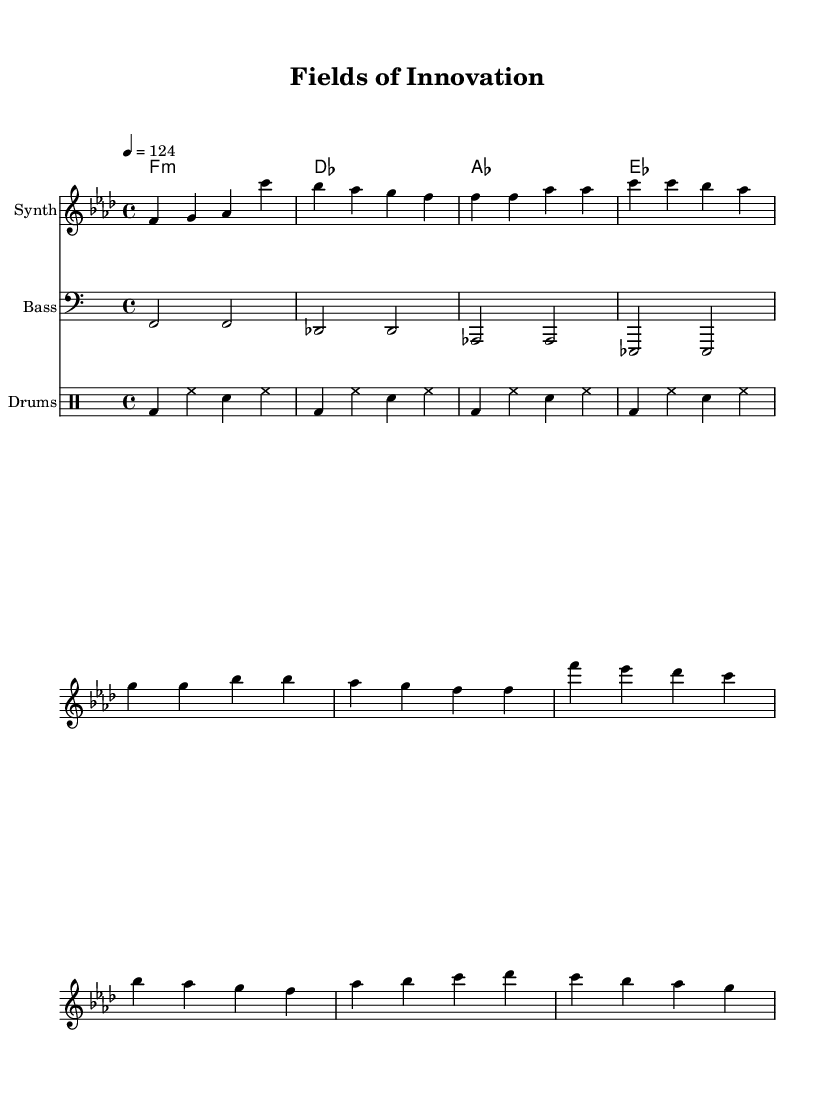What is the key signature of this music? The key signature is F minor, which contains four flats (B flat, E flat, A flat, and D flat). It can be found at the beginning of the staff, indicating the tonal center of the piece.
Answer: F minor What is the time signature of this music? The time signature is 4/4, shown at the beginning of the score. This indicates that there are four beats in each measure, and each beat is a quarter note long.
Answer: 4/4 What is the tempo marking for this piece? The tempo marking indicates a speed of 124 beats per minute. This can be interpreted in the tempo instruction found at the beginning of the score.
Answer: 124 How many measures are in the verse section? The verse section consists of 8 measures, which can be counted by identifying the individual groups of notes and chords that are organized within the staff.
Answer: 8 Which instrument plays the melody? The melody is played by the Synth, as indicated by the label on the staff. This title appears above the notes and denotes the specific instrument performing that part.
Answer: Synth What type of music is this composition classified as? This composition is classified as Deep House, as evidenced by its rhythmic structure, instrumentation, and the thematic content of the lyrics which focus on technological advancements in agriculture and sustainability.
Answer: Deep House What is the main theme expressed in the lyrics? The main theme in the lyrics expresses the integration of technology in agriculture, emphasizing sustainable practices and innovation to support farming and food production. This can be inferred from the content of the verse and chorus.
Answer: Technological advancements in agriculture 